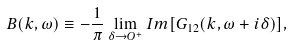Convert formula to latex. <formula><loc_0><loc_0><loc_500><loc_500>B ( { k } , \omega ) \equiv - \frac { 1 } { \pi } \lim _ { \delta \rightarrow O ^ { + } } I m [ G _ { 1 2 } ( { k } , \omega + i \delta ) ] ,</formula> 